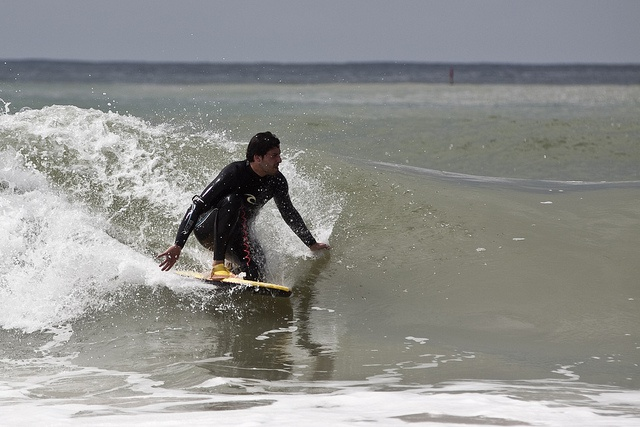Describe the objects in this image and their specific colors. I can see people in gray, black, maroon, and darkgray tones and surfboard in gray, black, lightgray, and beige tones in this image. 